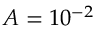Convert formula to latex. <formula><loc_0><loc_0><loc_500><loc_500>A = 1 0 ^ { - 2 }</formula> 